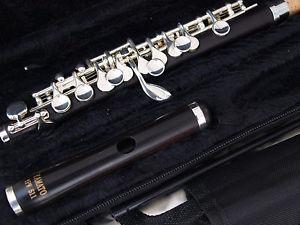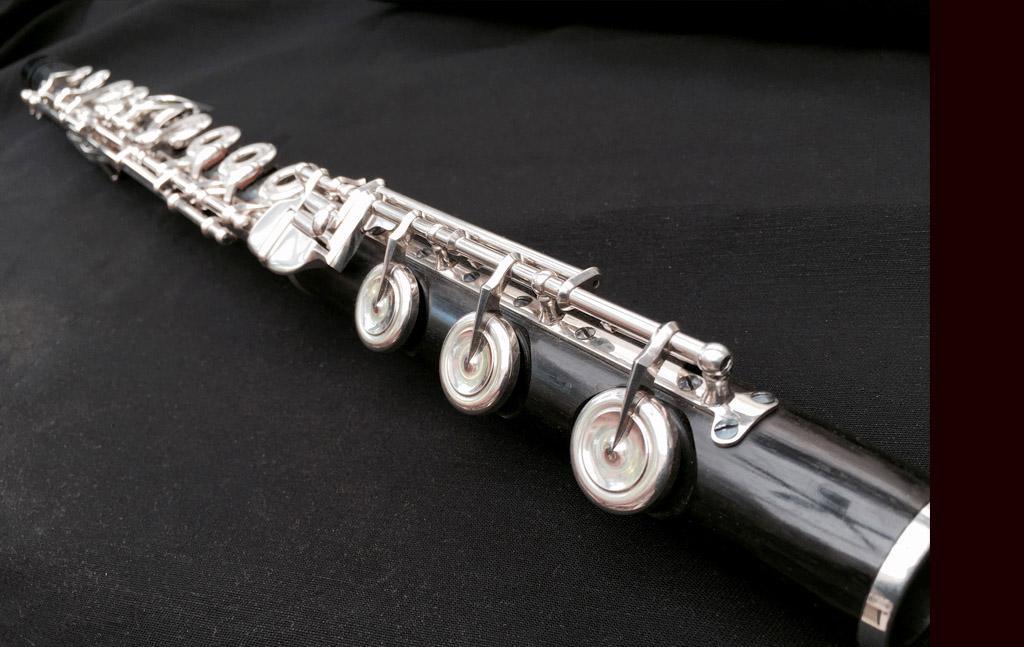The first image is the image on the left, the second image is the image on the right. Considering the images on both sides, is "There is exactly one assembled flute in the left image." valid? Answer yes or no. No. The first image is the image on the left, the second image is the image on the right. Evaluate the accuracy of this statement regarding the images: "There are two flutes and one of them is in two pieces.". Is it true? Answer yes or no. Yes. 